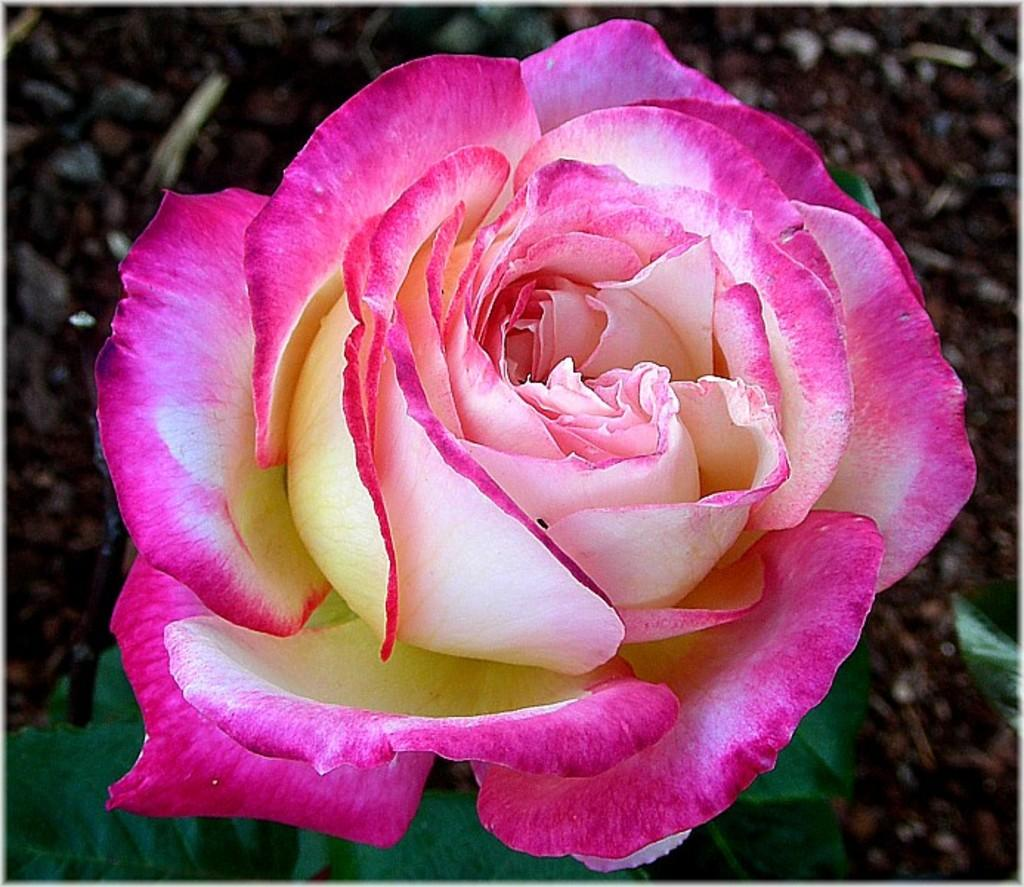What type of plant can be seen in the image? There is a flower in the image. What part of the flower is visible at the bottom of the image? Leaves are visible at the bottom of the image. What can be seen behind the flower in the image? The ground is visible behind the flower in the image. Can you tell me how the robin is helping the flower in the image? There is no robin present in the image, so it cannot be helping the flower. 